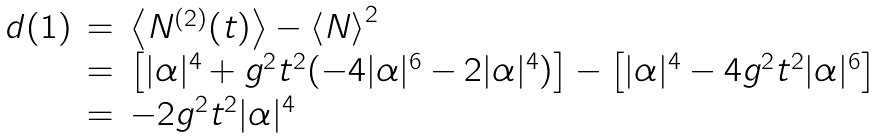Convert formula to latex. <formula><loc_0><loc_0><loc_500><loc_500>\begin{array} { l c l } d ( 1 ) & = & \left \langle N ^ { ( 2 ) } ( t ) \right \rangle - \left \langle N \right \rangle ^ { 2 } \\ & = & \left [ | \alpha | ^ { 4 } + g ^ { 2 } t ^ { 2 } ( - 4 | \alpha | ^ { 6 } - 2 | \alpha | ^ { 4 } ) \right ] - \left [ | \alpha | ^ { 4 } - 4 g ^ { 2 } t ^ { 2 } | \alpha | ^ { 6 } \right ] \\ & = & - 2 g ^ { 2 } t ^ { 2 } | \alpha | ^ { 4 } \end{array}</formula> 